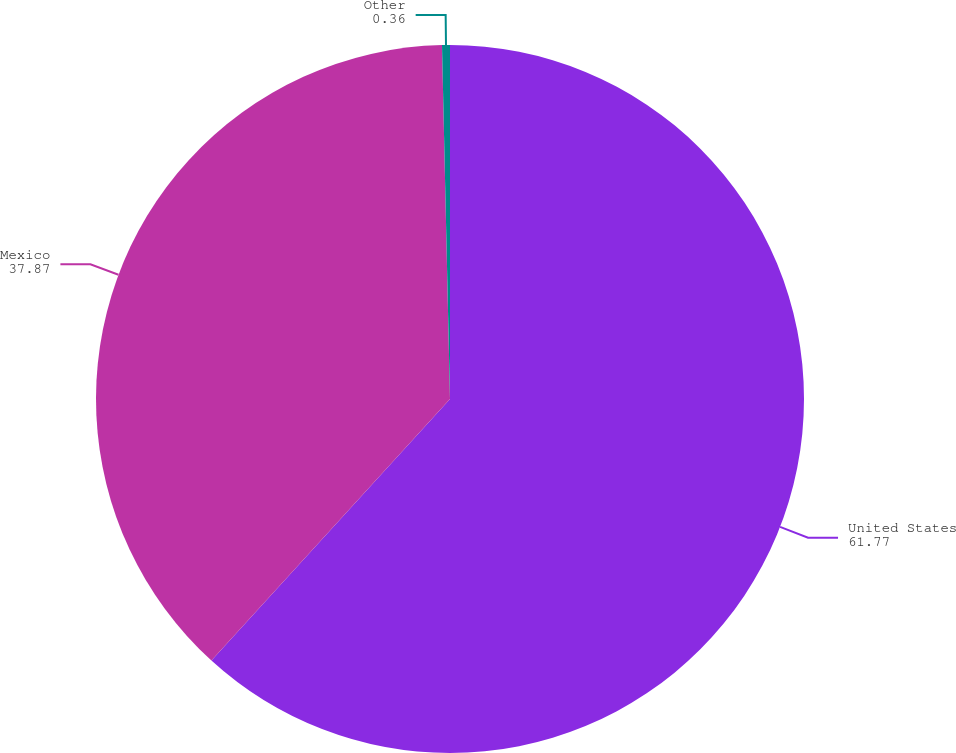Convert chart. <chart><loc_0><loc_0><loc_500><loc_500><pie_chart><fcel>United States<fcel>Mexico<fcel>Other<nl><fcel>61.77%<fcel>37.87%<fcel>0.36%<nl></chart> 